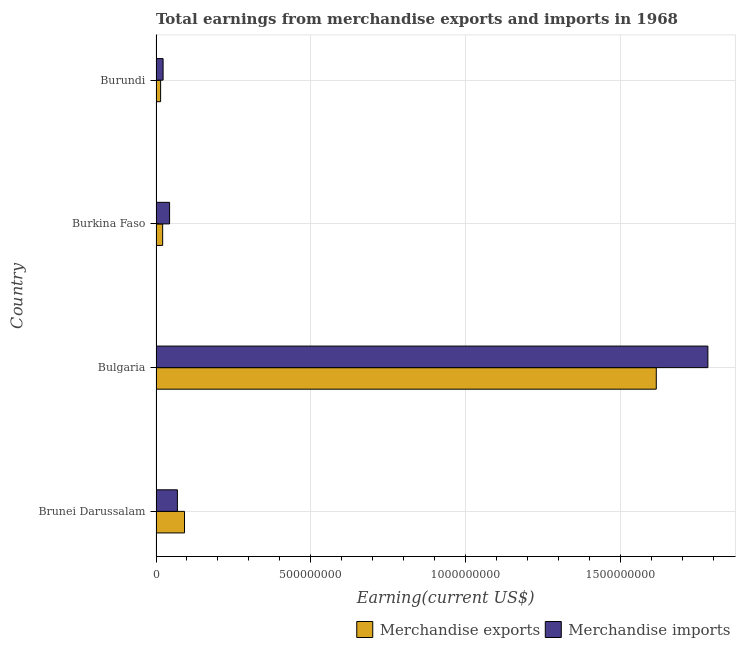What is the label of the 1st group of bars from the top?
Keep it short and to the point. Burundi. What is the earnings from merchandise exports in Brunei Darussalam?
Provide a succinct answer. 9.20e+07. Across all countries, what is the maximum earnings from merchandise exports?
Your answer should be very brief. 1.62e+09. Across all countries, what is the minimum earnings from merchandise imports?
Make the answer very short. 2.28e+07. In which country was the earnings from merchandise exports minimum?
Keep it short and to the point. Burundi. What is the total earnings from merchandise exports in the graph?
Your answer should be compact. 1.74e+09. What is the difference between the earnings from merchandise imports in Brunei Darussalam and that in Bulgaria?
Your answer should be compact. -1.71e+09. What is the difference between the earnings from merchandise imports in Bulgaria and the earnings from merchandise exports in Brunei Darussalam?
Provide a succinct answer. 1.69e+09. What is the average earnings from merchandise imports per country?
Provide a succinct answer. 4.79e+08. What is the difference between the earnings from merchandise exports and earnings from merchandise imports in Bulgaria?
Make the answer very short. -1.67e+08. What is the ratio of the earnings from merchandise imports in Bulgaria to that in Burkina Faso?
Make the answer very short. 40.72. Is the difference between the earnings from merchandise imports in Burkina Faso and Burundi greater than the difference between the earnings from merchandise exports in Burkina Faso and Burundi?
Your answer should be very brief. Yes. What is the difference between the highest and the second highest earnings from merchandise imports?
Provide a succinct answer. 1.71e+09. What is the difference between the highest and the lowest earnings from merchandise imports?
Offer a terse response. 1.76e+09. In how many countries, is the earnings from merchandise imports greater than the average earnings from merchandise imports taken over all countries?
Ensure brevity in your answer.  1. What does the 1st bar from the top in Brunei Darussalam represents?
Keep it short and to the point. Merchandise imports. Are all the bars in the graph horizontal?
Make the answer very short. Yes. What is the difference between two consecutive major ticks on the X-axis?
Offer a terse response. 5.00e+08. Are the values on the major ticks of X-axis written in scientific E-notation?
Offer a terse response. No. Where does the legend appear in the graph?
Give a very brief answer. Bottom right. How many legend labels are there?
Provide a succinct answer. 2. How are the legend labels stacked?
Provide a short and direct response. Horizontal. What is the title of the graph?
Your answer should be very brief. Total earnings from merchandise exports and imports in 1968. Does "Mineral" appear as one of the legend labels in the graph?
Provide a succinct answer. No. What is the label or title of the X-axis?
Your answer should be compact. Earning(current US$). What is the label or title of the Y-axis?
Your response must be concise. Country. What is the Earning(current US$) of Merchandise exports in Brunei Darussalam?
Provide a short and direct response. 9.20e+07. What is the Earning(current US$) in Merchandise imports in Brunei Darussalam?
Your response must be concise. 6.90e+07. What is the Earning(current US$) in Merchandise exports in Bulgaria?
Keep it short and to the point. 1.62e+09. What is the Earning(current US$) in Merchandise imports in Bulgaria?
Offer a very short reply. 1.78e+09. What is the Earning(current US$) of Merchandise exports in Burkina Faso?
Keep it short and to the point. 2.14e+07. What is the Earning(current US$) of Merchandise imports in Burkina Faso?
Provide a short and direct response. 4.38e+07. What is the Earning(current US$) in Merchandise exports in Burundi?
Give a very brief answer. 1.48e+07. What is the Earning(current US$) of Merchandise imports in Burundi?
Offer a very short reply. 2.28e+07. Across all countries, what is the maximum Earning(current US$) in Merchandise exports?
Keep it short and to the point. 1.62e+09. Across all countries, what is the maximum Earning(current US$) of Merchandise imports?
Keep it short and to the point. 1.78e+09. Across all countries, what is the minimum Earning(current US$) in Merchandise exports?
Provide a short and direct response. 1.48e+07. Across all countries, what is the minimum Earning(current US$) of Merchandise imports?
Your answer should be very brief. 2.28e+07. What is the total Earning(current US$) in Merchandise exports in the graph?
Offer a terse response. 1.74e+09. What is the total Earning(current US$) of Merchandise imports in the graph?
Your response must be concise. 1.92e+09. What is the difference between the Earning(current US$) in Merchandise exports in Brunei Darussalam and that in Bulgaria?
Provide a succinct answer. -1.52e+09. What is the difference between the Earning(current US$) of Merchandise imports in Brunei Darussalam and that in Bulgaria?
Ensure brevity in your answer.  -1.71e+09. What is the difference between the Earning(current US$) in Merchandise exports in Brunei Darussalam and that in Burkina Faso?
Your response must be concise. 7.06e+07. What is the difference between the Earning(current US$) in Merchandise imports in Brunei Darussalam and that in Burkina Faso?
Provide a succinct answer. 2.52e+07. What is the difference between the Earning(current US$) of Merchandise exports in Brunei Darussalam and that in Burundi?
Your response must be concise. 7.72e+07. What is the difference between the Earning(current US$) of Merchandise imports in Brunei Darussalam and that in Burundi?
Give a very brief answer. 4.62e+07. What is the difference between the Earning(current US$) of Merchandise exports in Bulgaria and that in Burkina Faso?
Offer a terse response. 1.59e+09. What is the difference between the Earning(current US$) of Merchandise imports in Bulgaria and that in Burkina Faso?
Provide a short and direct response. 1.74e+09. What is the difference between the Earning(current US$) of Merchandise exports in Bulgaria and that in Burundi?
Offer a very short reply. 1.60e+09. What is the difference between the Earning(current US$) in Merchandise imports in Bulgaria and that in Burundi?
Make the answer very short. 1.76e+09. What is the difference between the Earning(current US$) in Merchandise exports in Burkina Faso and that in Burundi?
Your answer should be very brief. 6.59e+06. What is the difference between the Earning(current US$) of Merchandise imports in Burkina Faso and that in Burundi?
Keep it short and to the point. 2.10e+07. What is the difference between the Earning(current US$) in Merchandise exports in Brunei Darussalam and the Earning(current US$) in Merchandise imports in Bulgaria?
Provide a succinct answer. -1.69e+09. What is the difference between the Earning(current US$) of Merchandise exports in Brunei Darussalam and the Earning(current US$) of Merchandise imports in Burkina Faso?
Your answer should be very brief. 4.82e+07. What is the difference between the Earning(current US$) of Merchandise exports in Brunei Darussalam and the Earning(current US$) of Merchandise imports in Burundi?
Provide a short and direct response. 6.92e+07. What is the difference between the Earning(current US$) in Merchandise exports in Bulgaria and the Earning(current US$) in Merchandise imports in Burkina Faso?
Provide a succinct answer. 1.57e+09. What is the difference between the Earning(current US$) of Merchandise exports in Bulgaria and the Earning(current US$) of Merchandise imports in Burundi?
Your answer should be compact. 1.59e+09. What is the difference between the Earning(current US$) in Merchandise exports in Burkina Faso and the Earning(current US$) in Merchandise imports in Burundi?
Make the answer very short. -1.39e+06. What is the average Earning(current US$) in Merchandise exports per country?
Make the answer very short. 4.36e+08. What is the average Earning(current US$) in Merchandise imports per country?
Give a very brief answer. 4.79e+08. What is the difference between the Earning(current US$) in Merchandise exports and Earning(current US$) in Merchandise imports in Brunei Darussalam?
Provide a short and direct response. 2.30e+07. What is the difference between the Earning(current US$) of Merchandise exports and Earning(current US$) of Merchandise imports in Bulgaria?
Provide a short and direct response. -1.67e+08. What is the difference between the Earning(current US$) in Merchandise exports and Earning(current US$) in Merchandise imports in Burkina Faso?
Offer a very short reply. -2.23e+07. What is the difference between the Earning(current US$) of Merchandise exports and Earning(current US$) of Merchandise imports in Burundi?
Make the answer very short. -7.98e+06. What is the ratio of the Earning(current US$) in Merchandise exports in Brunei Darussalam to that in Bulgaria?
Keep it short and to the point. 0.06. What is the ratio of the Earning(current US$) in Merchandise imports in Brunei Darussalam to that in Bulgaria?
Ensure brevity in your answer.  0.04. What is the ratio of the Earning(current US$) of Merchandise exports in Brunei Darussalam to that in Burkina Faso?
Provide a succinct answer. 4.29. What is the ratio of the Earning(current US$) in Merchandise imports in Brunei Darussalam to that in Burkina Faso?
Keep it short and to the point. 1.58. What is the ratio of the Earning(current US$) of Merchandise exports in Brunei Darussalam to that in Burundi?
Your response must be concise. 6.2. What is the ratio of the Earning(current US$) in Merchandise imports in Brunei Darussalam to that in Burundi?
Offer a very short reply. 3.02. What is the ratio of the Earning(current US$) of Merchandise exports in Bulgaria to that in Burkina Faso?
Your response must be concise. 75.41. What is the ratio of the Earning(current US$) in Merchandise imports in Bulgaria to that in Burkina Faso?
Your answer should be very brief. 40.72. What is the ratio of the Earning(current US$) in Merchandise exports in Bulgaria to that in Burundi?
Offer a terse response. 108.91. What is the ratio of the Earning(current US$) of Merchandise imports in Bulgaria to that in Burundi?
Offer a terse response. 78.12. What is the ratio of the Earning(current US$) in Merchandise exports in Burkina Faso to that in Burundi?
Your response must be concise. 1.44. What is the ratio of the Earning(current US$) in Merchandise imports in Burkina Faso to that in Burundi?
Provide a short and direct response. 1.92. What is the difference between the highest and the second highest Earning(current US$) of Merchandise exports?
Your answer should be very brief. 1.52e+09. What is the difference between the highest and the second highest Earning(current US$) in Merchandise imports?
Provide a short and direct response. 1.71e+09. What is the difference between the highest and the lowest Earning(current US$) of Merchandise exports?
Your response must be concise. 1.60e+09. What is the difference between the highest and the lowest Earning(current US$) of Merchandise imports?
Offer a very short reply. 1.76e+09. 